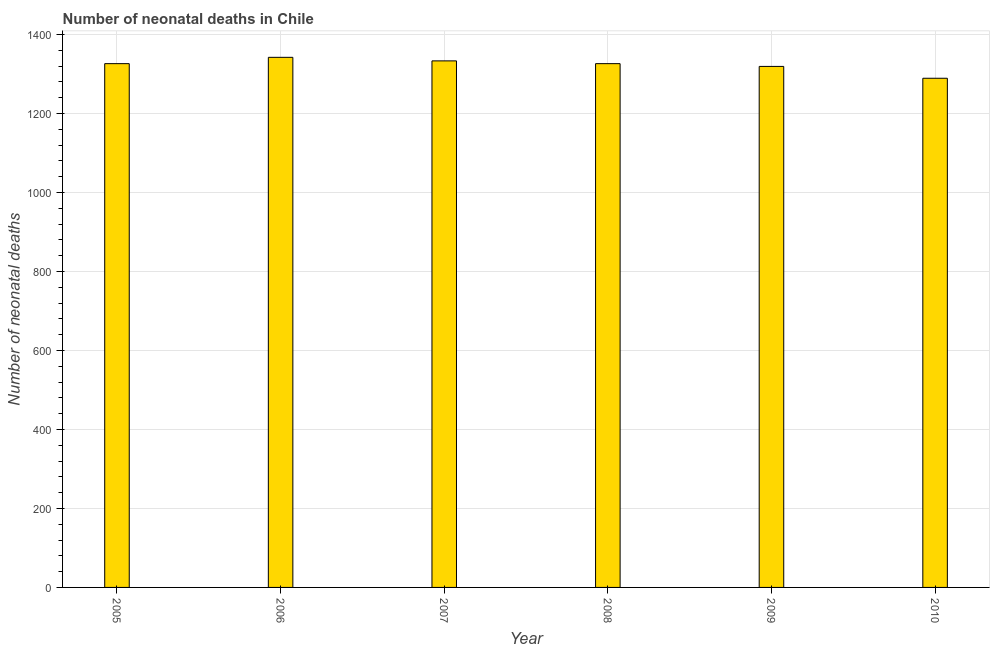Does the graph contain any zero values?
Keep it short and to the point. No. What is the title of the graph?
Make the answer very short. Number of neonatal deaths in Chile. What is the label or title of the X-axis?
Your answer should be very brief. Year. What is the label or title of the Y-axis?
Give a very brief answer. Number of neonatal deaths. What is the number of neonatal deaths in 2009?
Ensure brevity in your answer.  1319. Across all years, what is the maximum number of neonatal deaths?
Your answer should be compact. 1342. Across all years, what is the minimum number of neonatal deaths?
Your answer should be compact. 1289. In which year was the number of neonatal deaths minimum?
Your answer should be very brief. 2010. What is the sum of the number of neonatal deaths?
Your response must be concise. 7935. What is the average number of neonatal deaths per year?
Offer a terse response. 1322. What is the median number of neonatal deaths?
Your response must be concise. 1326. Is the number of neonatal deaths in 2007 less than that in 2009?
Your answer should be compact. No. Is the difference between the number of neonatal deaths in 2005 and 2010 greater than the difference between any two years?
Give a very brief answer. No. What is the difference between the highest and the second highest number of neonatal deaths?
Provide a short and direct response. 9. Is the sum of the number of neonatal deaths in 2006 and 2008 greater than the maximum number of neonatal deaths across all years?
Offer a terse response. Yes. In how many years, is the number of neonatal deaths greater than the average number of neonatal deaths taken over all years?
Your answer should be very brief. 4. How many bars are there?
Provide a short and direct response. 6. Are all the bars in the graph horizontal?
Keep it short and to the point. No. How many years are there in the graph?
Provide a short and direct response. 6. Are the values on the major ticks of Y-axis written in scientific E-notation?
Offer a terse response. No. What is the Number of neonatal deaths in 2005?
Ensure brevity in your answer.  1326. What is the Number of neonatal deaths of 2006?
Keep it short and to the point. 1342. What is the Number of neonatal deaths of 2007?
Your answer should be compact. 1333. What is the Number of neonatal deaths in 2008?
Keep it short and to the point. 1326. What is the Number of neonatal deaths of 2009?
Your answer should be very brief. 1319. What is the Number of neonatal deaths of 2010?
Ensure brevity in your answer.  1289. What is the difference between the Number of neonatal deaths in 2005 and 2007?
Keep it short and to the point. -7. What is the difference between the Number of neonatal deaths in 2006 and 2007?
Offer a very short reply. 9. What is the difference between the Number of neonatal deaths in 2006 and 2008?
Your answer should be compact. 16. What is the difference between the Number of neonatal deaths in 2006 and 2010?
Ensure brevity in your answer.  53. What is the difference between the Number of neonatal deaths in 2007 and 2008?
Make the answer very short. 7. What is the difference between the Number of neonatal deaths in 2007 and 2010?
Provide a succinct answer. 44. What is the difference between the Number of neonatal deaths in 2008 and 2009?
Your answer should be compact. 7. What is the difference between the Number of neonatal deaths in 2008 and 2010?
Provide a short and direct response. 37. What is the difference between the Number of neonatal deaths in 2009 and 2010?
Your answer should be compact. 30. What is the ratio of the Number of neonatal deaths in 2005 to that in 2008?
Offer a terse response. 1. What is the ratio of the Number of neonatal deaths in 2005 to that in 2010?
Your response must be concise. 1.03. What is the ratio of the Number of neonatal deaths in 2006 to that in 2008?
Offer a very short reply. 1.01. What is the ratio of the Number of neonatal deaths in 2006 to that in 2010?
Provide a succinct answer. 1.04. What is the ratio of the Number of neonatal deaths in 2007 to that in 2008?
Keep it short and to the point. 1. What is the ratio of the Number of neonatal deaths in 2007 to that in 2009?
Your response must be concise. 1.01. What is the ratio of the Number of neonatal deaths in 2007 to that in 2010?
Provide a short and direct response. 1.03. What is the ratio of the Number of neonatal deaths in 2008 to that in 2009?
Ensure brevity in your answer.  1. What is the ratio of the Number of neonatal deaths in 2008 to that in 2010?
Your answer should be very brief. 1.03. What is the ratio of the Number of neonatal deaths in 2009 to that in 2010?
Your answer should be very brief. 1.02. 